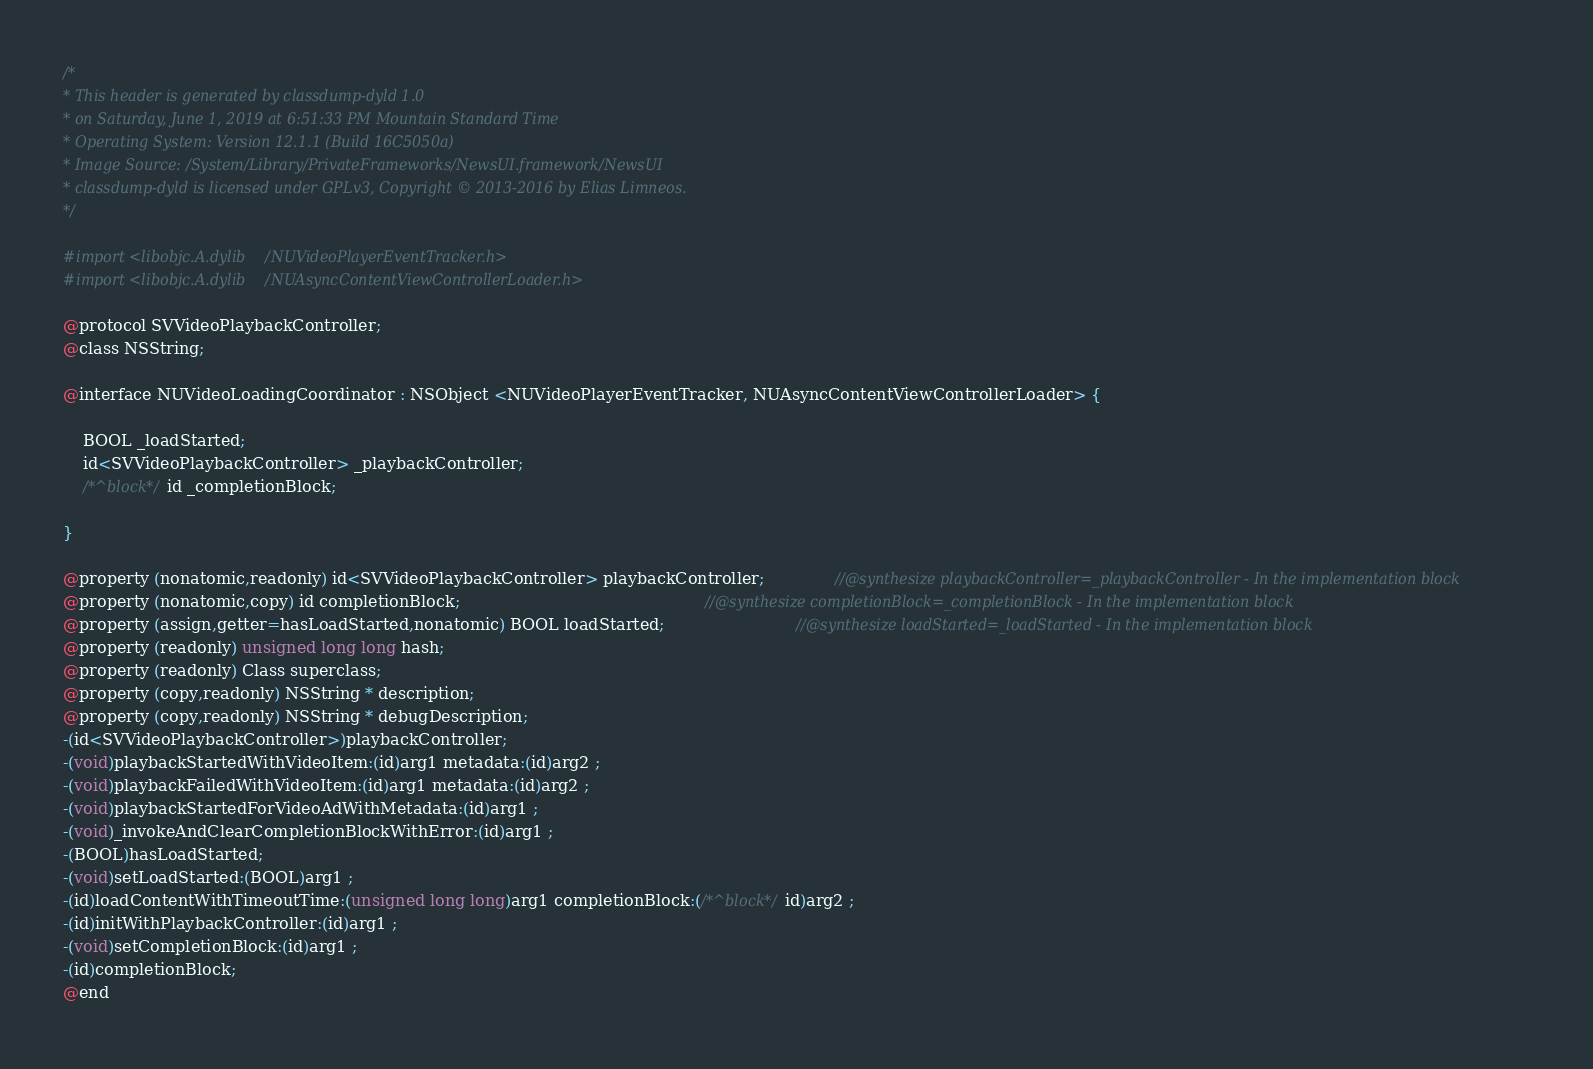Convert code to text. <code><loc_0><loc_0><loc_500><loc_500><_C_>/*
* This header is generated by classdump-dyld 1.0
* on Saturday, June 1, 2019 at 6:51:33 PM Mountain Standard Time
* Operating System: Version 12.1.1 (Build 16C5050a)
* Image Source: /System/Library/PrivateFrameworks/NewsUI.framework/NewsUI
* classdump-dyld is licensed under GPLv3, Copyright © 2013-2016 by Elias Limneos.
*/

#import <libobjc.A.dylib/NUVideoPlayerEventTracker.h>
#import <libobjc.A.dylib/NUAsyncContentViewControllerLoader.h>

@protocol SVVideoPlaybackController;
@class NSString;

@interface NUVideoLoadingCoordinator : NSObject <NUVideoPlayerEventTracker, NUAsyncContentViewControllerLoader> {

	BOOL _loadStarted;
	id<SVVideoPlaybackController> _playbackController;
	/*^block*/id _completionBlock;

}

@property (nonatomic,readonly) id<SVVideoPlaybackController> playbackController;              //@synthesize playbackController=_playbackController - In the implementation block
@property (nonatomic,copy) id completionBlock;                                                //@synthesize completionBlock=_completionBlock - In the implementation block
@property (assign,getter=hasLoadStarted,nonatomic) BOOL loadStarted;                          //@synthesize loadStarted=_loadStarted - In the implementation block
@property (readonly) unsigned long long hash; 
@property (readonly) Class superclass; 
@property (copy,readonly) NSString * description; 
@property (copy,readonly) NSString * debugDescription; 
-(id<SVVideoPlaybackController>)playbackController;
-(void)playbackStartedWithVideoItem:(id)arg1 metadata:(id)arg2 ;
-(void)playbackFailedWithVideoItem:(id)arg1 metadata:(id)arg2 ;
-(void)playbackStartedForVideoAdWithMetadata:(id)arg1 ;
-(void)_invokeAndClearCompletionBlockWithError:(id)arg1 ;
-(BOOL)hasLoadStarted;
-(void)setLoadStarted:(BOOL)arg1 ;
-(id)loadContentWithTimeoutTime:(unsigned long long)arg1 completionBlock:(/*^block*/id)arg2 ;
-(id)initWithPlaybackController:(id)arg1 ;
-(void)setCompletionBlock:(id)arg1 ;
-(id)completionBlock;
@end

</code> 